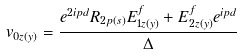Convert formula to latex. <formula><loc_0><loc_0><loc_500><loc_500>v _ { 0 z ( y ) } = \frac { e ^ { 2 i p d } R _ { 2 p ( s ) } E ^ { f } _ { 1 z ( y ) } + E ^ { f } _ { 2 z ( y ) } e ^ { i p d } } { \Delta }</formula> 